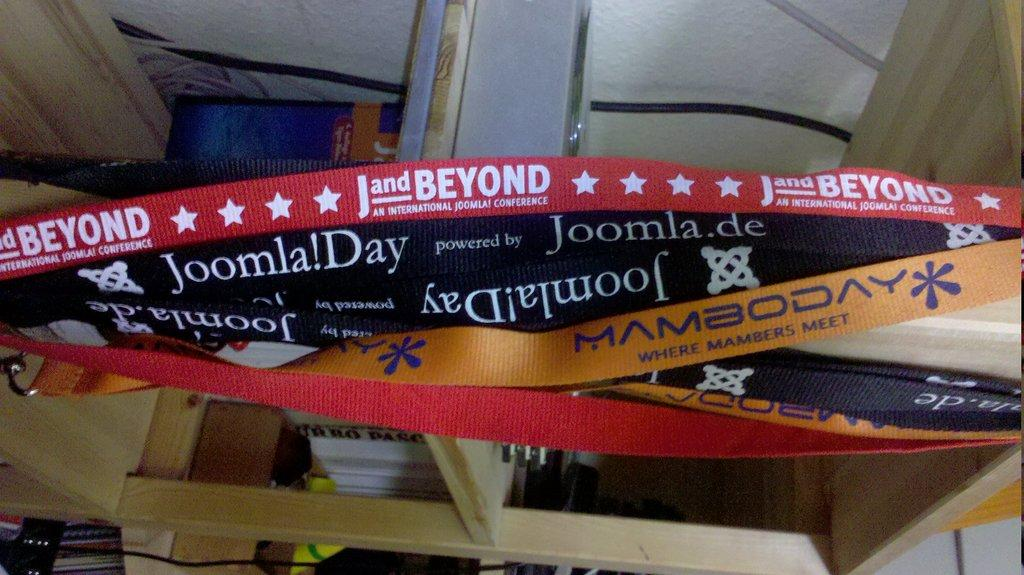<image>
Offer a succinct explanation of the picture presented. A pile of lanyards that say Joomla!Day are hanging on a shelf. 